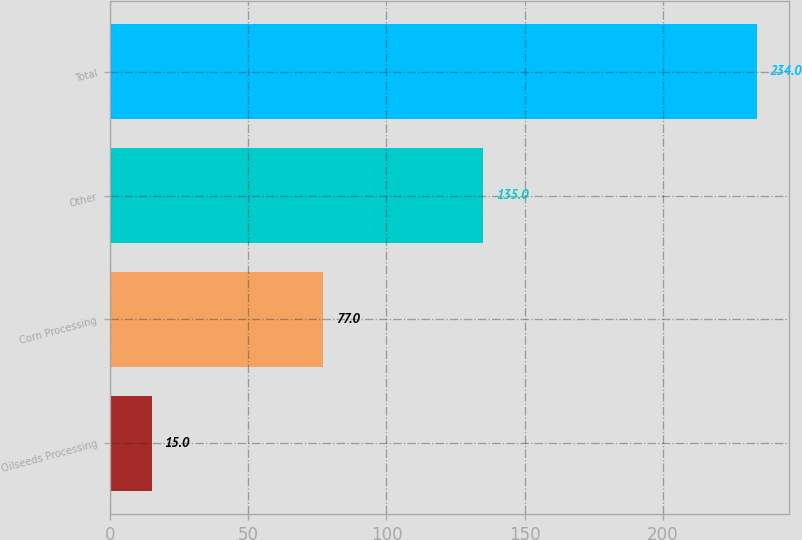Convert chart to OTSL. <chart><loc_0><loc_0><loc_500><loc_500><bar_chart><fcel>Oilseeds Processing<fcel>Corn Processing<fcel>Other<fcel>Total<nl><fcel>15<fcel>77<fcel>135<fcel>234<nl></chart> 